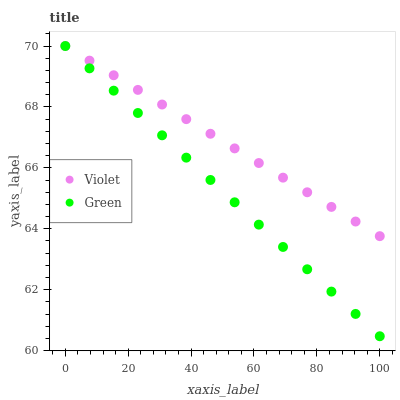Does Green have the minimum area under the curve?
Answer yes or no. Yes. Does Violet have the maximum area under the curve?
Answer yes or no. Yes. Does Violet have the minimum area under the curve?
Answer yes or no. No. Is Green the smoothest?
Answer yes or no. Yes. Is Violet the roughest?
Answer yes or no. Yes. Is Violet the smoothest?
Answer yes or no. No. Does Green have the lowest value?
Answer yes or no. Yes. Does Violet have the lowest value?
Answer yes or no. No. Does Violet have the highest value?
Answer yes or no. Yes. Does Violet intersect Green?
Answer yes or no. Yes. Is Violet less than Green?
Answer yes or no. No. Is Violet greater than Green?
Answer yes or no. No. 